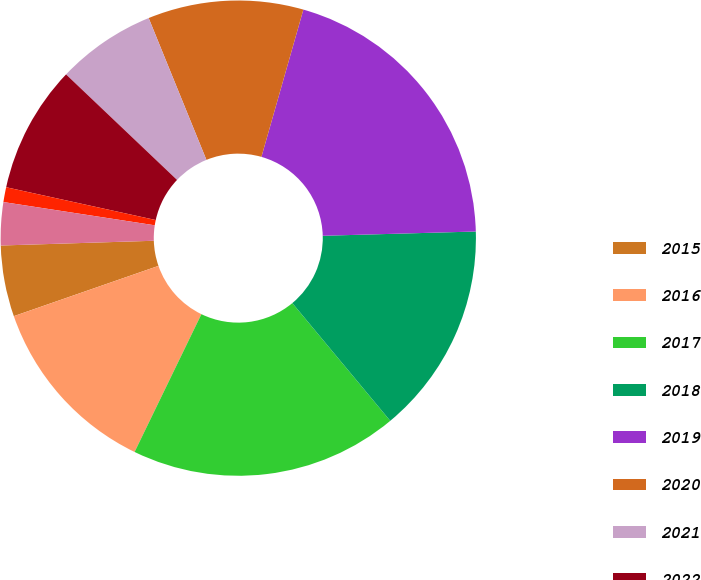<chart> <loc_0><loc_0><loc_500><loc_500><pie_chart><fcel>2015<fcel>2016<fcel>2017<fcel>2018<fcel>2019<fcel>2020<fcel>2021<fcel>2022<fcel>2023<fcel>2024<nl><fcel>4.83%<fcel>12.49%<fcel>18.23%<fcel>14.4%<fcel>20.14%<fcel>10.57%<fcel>6.75%<fcel>8.66%<fcel>1.01%<fcel>2.92%<nl></chart> 